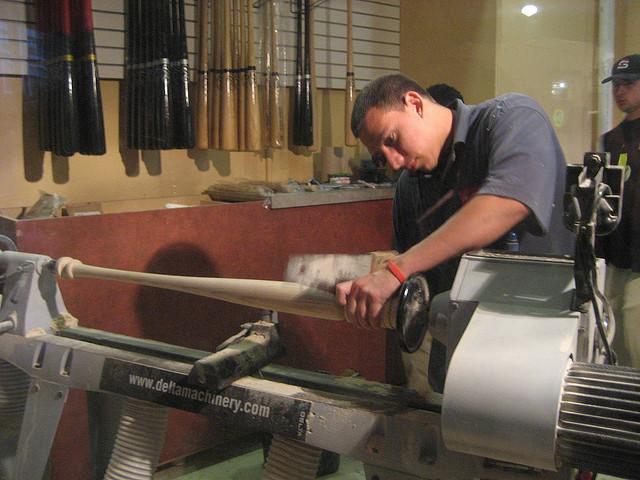How many people can you see?
Give a very brief answer. 2. How many cars are in the scene?
Give a very brief answer. 0. 